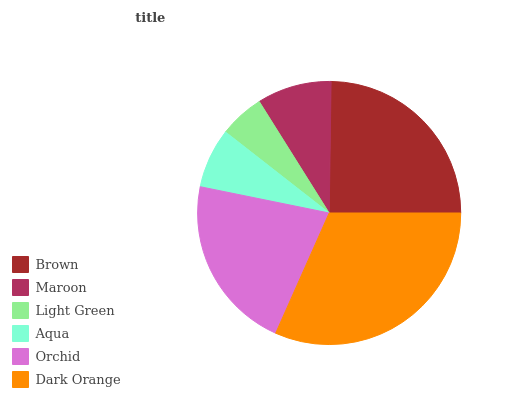Is Light Green the minimum?
Answer yes or no. Yes. Is Dark Orange the maximum?
Answer yes or no. Yes. Is Maroon the minimum?
Answer yes or no. No. Is Maroon the maximum?
Answer yes or no. No. Is Brown greater than Maroon?
Answer yes or no. Yes. Is Maroon less than Brown?
Answer yes or no. Yes. Is Maroon greater than Brown?
Answer yes or no. No. Is Brown less than Maroon?
Answer yes or no. No. Is Orchid the high median?
Answer yes or no. Yes. Is Maroon the low median?
Answer yes or no. Yes. Is Dark Orange the high median?
Answer yes or no. No. Is Dark Orange the low median?
Answer yes or no. No. 